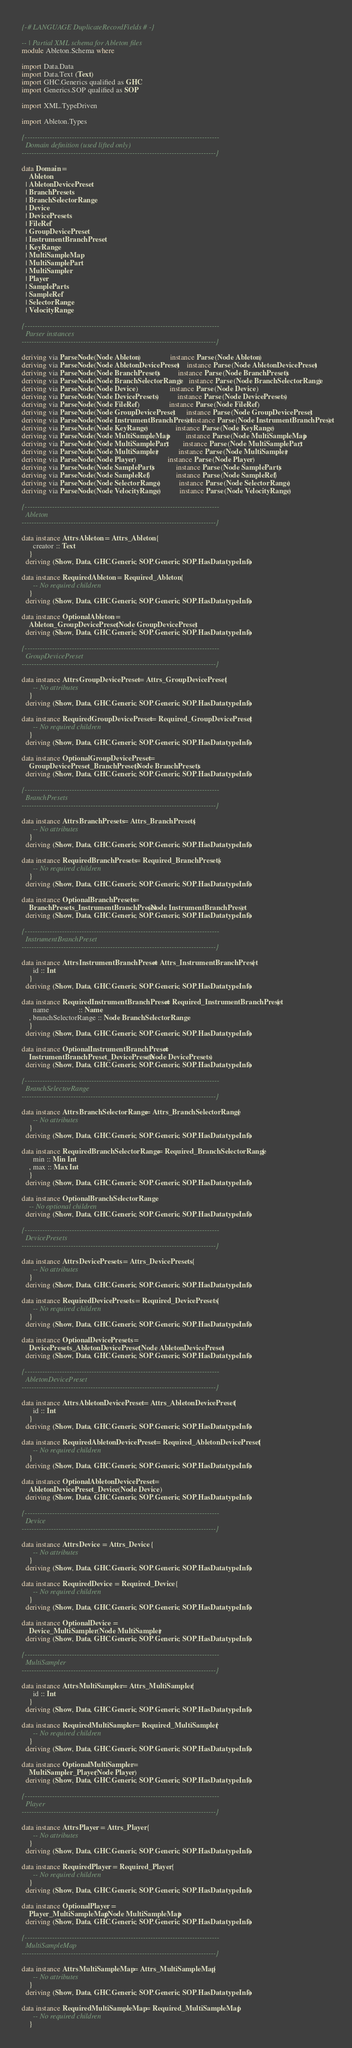Convert code to text. <code><loc_0><loc_0><loc_500><loc_500><_Haskell_>{-# LANGUAGE DuplicateRecordFields #-}

-- | Partial XML schema for Ableton files
module Ableton.Schema where

import Data.Data
import Data.Text (Text)
import GHC.Generics qualified as GHC
import Generics.SOP qualified as SOP

import XML.TypeDriven

import Ableton.Types

{-------------------------------------------------------------------------------
  Domain definition (used lifted only)
-------------------------------------------------------------------------------}

data Domain =
    Ableton
  | AbletonDevicePreset
  | BranchPresets
  | BranchSelectorRange
  | Device
  | DevicePresets
  | FileRef
  | GroupDevicePreset
  | InstrumentBranchPreset
  | KeyRange
  | MultiSampleMap
  | MultiSamplePart
  | MultiSampler
  | Player
  | SampleParts
  | SampleRef
  | SelectorRange
  | VelocityRange

{-------------------------------------------------------------------------------
  Parser instances
-------------------------------------------------------------------------------}

deriving via ParseNode (Node Ableton)                instance Parse (Node Ableton)
deriving via ParseNode (Node AbletonDevicePreset)    instance Parse (Node AbletonDevicePreset)
deriving via ParseNode (Node BranchPresets)          instance Parse (Node BranchPresets)
deriving via ParseNode (Node BranchSelectorRange)    instance Parse (Node BranchSelectorRange)
deriving via ParseNode (Node Device)                 instance Parse (Node Device)
deriving via ParseNode (Node DevicePresets)          instance Parse (Node DevicePresets)
deriving via ParseNode (Node FileRef)                instance Parse (Node FileRef)
deriving via ParseNode (Node GroupDevicePreset)      instance Parse (Node GroupDevicePreset)
deriving via ParseNode (Node InstrumentBranchPreset) instance Parse (Node InstrumentBranchPreset)
deriving via ParseNode (Node KeyRange)               instance Parse (Node KeyRange)
deriving via ParseNode (Node MultiSampleMap)         instance Parse (Node MultiSampleMap)
deriving via ParseNode (Node MultiSamplePart)        instance Parse (Node MultiSamplePart)
deriving via ParseNode (Node MultiSampler)           instance Parse (Node MultiSampler)
deriving via ParseNode (Node Player)                 instance Parse (Node Player)
deriving via ParseNode (Node SampleParts)            instance Parse (Node SampleParts)
deriving via ParseNode (Node SampleRef)              instance Parse (Node SampleRef)
deriving via ParseNode (Node SelectorRange)          instance Parse (Node SelectorRange)
deriving via ParseNode (Node VelocityRange)          instance Parse (Node VelocityRange)

{-------------------------------------------------------------------------------
  Ableton
-------------------------------------------------------------------------------}

data instance Attrs Ableton = Attrs_Ableton {
      creator :: Text
    }
  deriving (Show, Data, GHC.Generic, SOP.Generic, SOP.HasDatatypeInfo)

data instance Required Ableton = Required_Ableton {
      -- No required children
    }
  deriving (Show, Data, GHC.Generic, SOP.Generic, SOP.HasDatatypeInfo)

data instance Optional Ableton =
    Ableton_GroupDevicePreset (Node GroupDevicePreset)
  deriving (Show, Data, GHC.Generic, SOP.Generic, SOP.HasDatatypeInfo)

{-------------------------------------------------------------------------------
  GroupDevicePreset
-------------------------------------------------------------------------------}

data instance Attrs GroupDevicePreset = Attrs_GroupDevicePreset {
      -- No attributes
    }
  deriving (Show, Data, GHC.Generic, SOP.Generic, SOP.HasDatatypeInfo)

data instance Required GroupDevicePreset = Required_GroupDevicePreset {
      -- No required children
    }
  deriving (Show, Data, GHC.Generic, SOP.Generic, SOP.HasDatatypeInfo)

data instance Optional GroupDevicePreset =
    GroupDevicePreset_BranchPresets (Node BranchPresets)
  deriving (Show, Data, GHC.Generic, SOP.Generic, SOP.HasDatatypeInfo)

{-------------------------------------------------------------------------------
  BranchPresets
-------------------------------------------------------------------------------}

data instance Attrs BranchPresets = Attrs_BranchPresets {
      -- No attributes
    }
  deriving (Show, Data, GHC.Generic, SOP.Generic, SOP.HasDatatypeInfo)

data instance Required BranchPresets = Required_BranchPresets {
      -- No required children
    }
  deriving (Show, Data, GHC.Generic, SOP.Generic, SOP.HasDatatypeInfo)

data instance Optional BranchPresets =
    BranchPresets_InstrumentBranchPreset (Node InstrumentBranchPreset)
  deriving (Show, Data, GHC.Generic, SOP.Generic, SOP.HasDatatypeInfo)

{-------------------------------------------------------------------------------
  InstrumentBranchPreset
-------------------------------------------------------------------------------}

data instance Attrs InstrumentBranchPreset = Attrs_InstrumentBranchPreset {
      id :: Int
    }
  deriving (Show, Data, GHC.Generic, SOP.Generic, SOP.HasDatatypeInfo)

data instance Required InstrumentBranchPreset = Required_InstrumentBranchPreset {
      name                :: Name
    , branchSelectorRange :: Node BranchSelectorRange
    }
  deriving (Show, Data, GHC.Generic, SOP.Generic, SOP.HasDatatypeInfo)

data instance Optional InstrumentBranchPreset =
    InstrumentBranchPreset_DevicePresets (Node DevicePresets)
  deriving (Show, Data, GHC.Generic, SOP.Generic, SOP.HasDatatypeInfo)

{-------------------------------------------------------------------------------
  BranchSelectorRange
-------------------------------------------------------------------------------}

data instance Attrs BranchSelectorRange = Attrs_BranchSelectorRange {
      -- No attributes
    }
  deriving (Show, Data, GHC.Generic, SOP.Generic, SOP.HasDatatypeInfo)

data instance Required BranchSelectorRange = Required_BranchSelectorRange {
      min :: Min Int
    , max :: Max Int
    }
  deriving (Show, Data, GHC.Generic, SOP.Generic, SOP.HasDatatypeInfo)

data instance Optional BranchSelectorRange
    -- No optional children
  deriving (Show, Data, GHC.Generic, SOP.Generic, SOP.HasDatatypeInfo)

{-------------------------------------------------------------------------------
  DevicePresets
-------------------------------------------------------------------------------}

data instance Attrs DevicePresets = Attrs_DevicePresets {
      -- No attributes
    }
  deriving (Show, Data, GHC.Generic, SOP.Generic, SOP.HasDatatypeInfo)

data instance Required DevicePresets = Required_DevicePresets {
      -- No required children
    }
  deriving (Show, Data, GHC.Generic, SOP.Generic, SOP.HasDatatypeInfo)

data instance Optional DevicePresets =
    DevicePresets_AbletonDevicePreset (Node AbletonDevicePreset)
  deriving (Show, Data, GHC.Generic, SOP.Generic, SOP.HasDatatypeInfo)

{-------------------------------------------------------------------------------
  AbletonDevicePreset
-------------------------------------------------------------------------------}

data instance Attrs AbletonDevicePreset = Attrs_AbletonDevicePreset {
      id :: Int
    }
  deriving (Show, Data, GHC.Generic, SOP.Generic, SOP.HasDatatypeInfo)

data instance Required AbletonDevicePreset = Required_AbletonDevicePreset {
      -- No required children
    }
  deriving (Show, Data, GHC.Generic, SOP.Generic, SOP.HasDatatypeInfo)

data instance Optional AbletonDevicePreset =
    AbletonDevicePreset_Device (Node Device)
  deriving (Show, Data, GHC.Generic, SOP.Generic, SOP.HasDatatypeInfo)

{-------------------------------------------------------------------------------
  Device
-------------------------------------------------------------------------------}

data instance Attrs Device = Attrs_Device {
      -- No attributes
    }
  deriving (Show, Data, GHC.Generic, SOP.Generic, SOP.HasDatatypeInfo)

data instance Required Device = Required_Device {
      -- No required children
    }
  deriving (Show, Data, GHC.Generic, SOP.Generic, SOP.HasDatatypeInfo)

data instance Optional Device =
    Device_MultiSampler (Node MultiSampler)
  deriving (Show, Data, GHC.Generic, SOP.Generic, SOP.HasDatatypeInfo)

{-------------------------------------------------------------------------------
  MultiSampler
-------------------------------------------------------------------------------}

data instance Attrs MultiSampler = Attrs_MultiSampler {
      id :: Int
    }
  deriving (Show, Data, GHC.Generic, SOP.Generic, SOP.HasDatatypeInfo)

data instance Required MultiSampler = Required_MultiSampler {
      -- No required children
    }
  deriving (Show, Data, GHC.Generic, SOP.Generic, SOP.HasDatatypeInfo)

data instance Optional MultiSampler =
    MultiSampler_Player (Node Player)
  deriving (Show, Data, GHC.Generic, SOP.Generic, SOP.HasDatatypeInfo)

{-------------------------------------------------------------------------------
  Player
-------------------------------------------------------------------------------}

data instance Attrs Player = Attrs_Player {
      -- No attributes
    }
  deriving (Show, Data, GHC.Generic, SOP.Generic, SOP.HasDatatypeInfo)

data instance Required Player = Required_Player {
      -- No required children
    }
  deriving (Show, Data, GHC.Generic, SOP.Generic, SOP.HasDatatypeInfo)

data instance Optional Player =
    Player_MultiSampleMap (Node MultiSampleMap)
  deriving (Show, Data, GHC.Generic, SOP.Generic, SOP.HasDatatypeInfo)

{-------------------------------------------------------------------------------
  MultiSampleMap
-------------------------------------------------------------------------------}

data instance Attrs MultiSampleMap = Attrs_MultiSampleMap {
      -- No attributes
    }
  deriving (Show, Data, GHC.Generic, SOP.Generic, SOP.HasDatatypeInfo)

data instance Required MultiSampleMap = Required_MultiSampleMap {
      -- No required children
    }</code> 